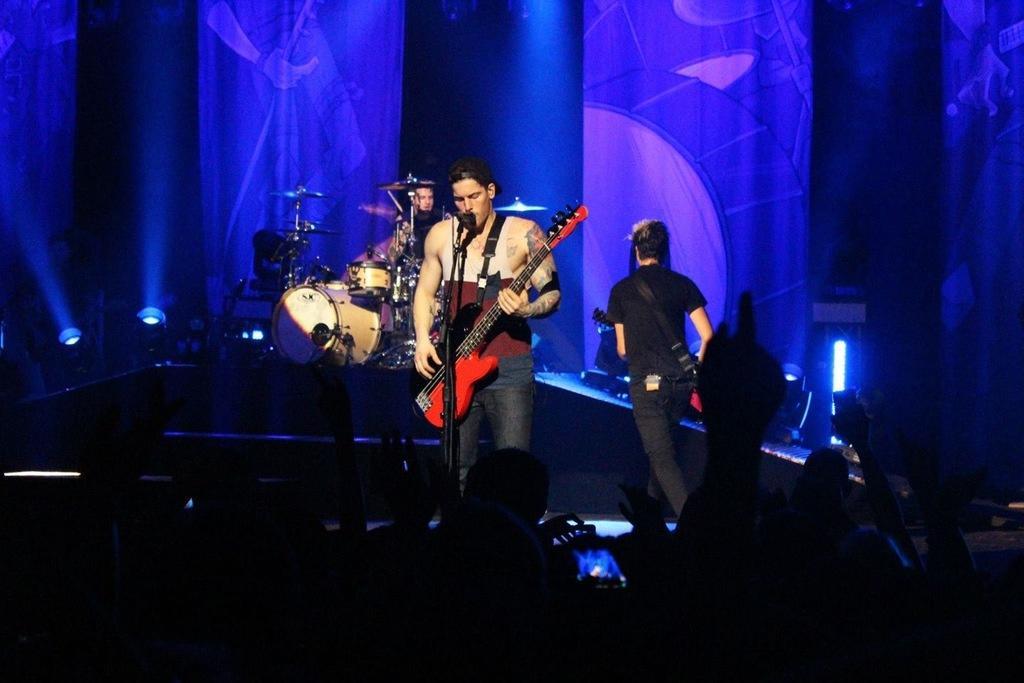Please provide a concise description of this image. This person is standing and playing a guitar in-front of mic. These are audience. This man is walking and holding a guitar. This person is sitting and playing these musical instruments. Far there is a light. 